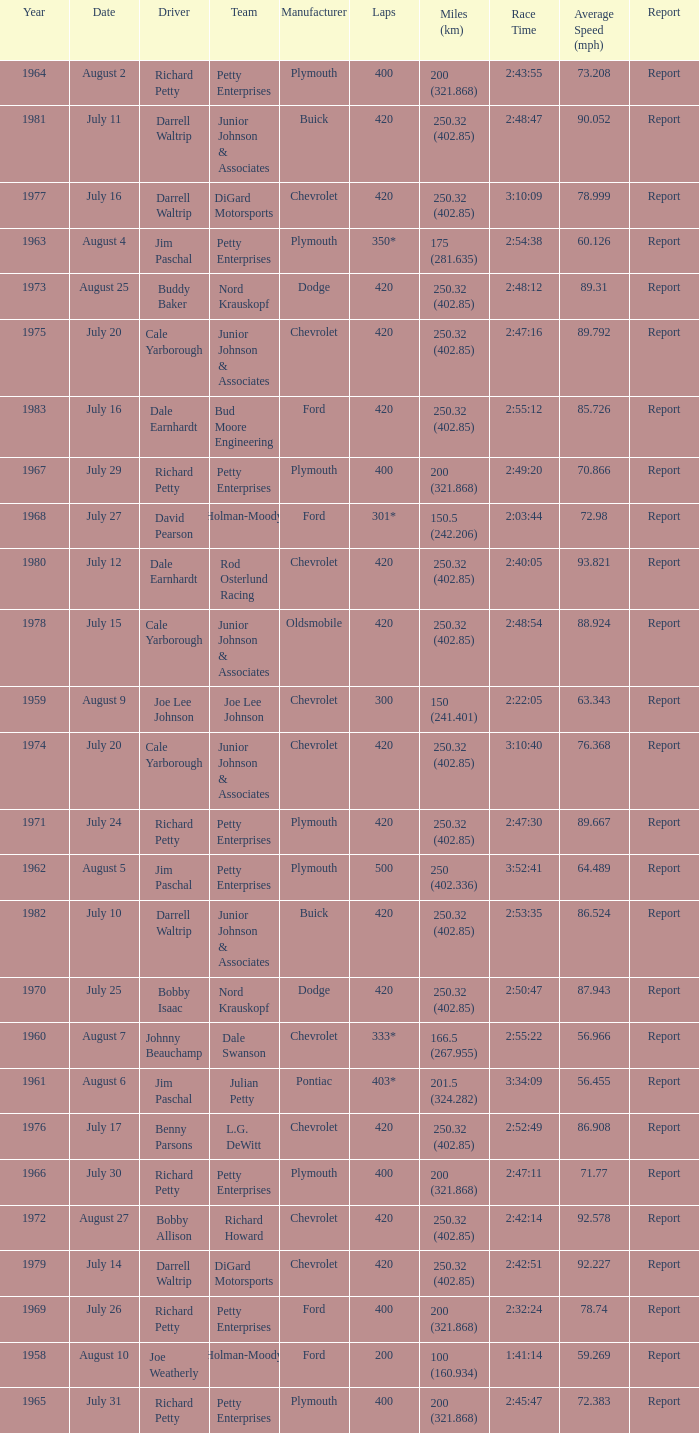Give me the full table as a dictionary. {'header': ['Year', 'Date', 'Driver', 'Team', 'Manufacturer', 'Laps', 'Miles (km)', 'Race Time', 'Average Speed (mph)', 'Report'], 'rows': [['1964', 'August 2', 'Richard Petty', 'Petty Enterprises', 'Plymouth', '400', '200 (321.868)', '2:43:55', '73.208', 'Report'], ['1981', 'July 11', 'Darrell Waltrip', 'Junior Johnson & Associates', 'Buick', '420', '250.32 (402.85)', '2:48:47', '90.052', 'Report'], ['1977', 'July 16', 'Darrell Waltrip', 'DiGard Motorsports', 'Chevrolet', '420', '250.32 (402.85)', '3:10:09', '78.999', 'Report'], ['1963', 'August 4', 'Jim Paschal', 'Petty Enterprises', 'Plymouth', '350*', '175 (281.635)', '2:54:38', '60.126', 'Report'], ['1973', 'August 25', 'Buddy Baker', 'Nord Krauskopf', 'Dodge', '420', '250.32 (402.85)', '2:48:12', '89.31', 'Report'], ['1975', 'July 20', 'Cale Yarborough', 'Junior Johnson & Associates', 'Chevrolet', '420', '250.32 (402.85)', '2:47:16', '89.792', 'Report'], ['1983', 'July 16', 'Dale Earnhardt', 'Bud Moore Engineering', 'Ford', '420', '250.32 (402.85)', '2:55:12', '85.726', 'Report'], ['1967', 'July 29', 'Richard Petty', 'Petty Enterprises', 'Plymouth', '400', '200 (321.868)', '2:49:20', '70.866', 'Report'], ['1968', 'July 27', 'David Pearson', 'Holman-Moody', 'Ford', '301*', '150.5 (242.206)', '2:03:44', '72.98', 'Report'], ['1980', 'July 12', 'Dale Earnhardt', 'Rod Osterlund Racing', 'Chevrolet', '420', '250.32 (402.85)', '2:40:05', '93.821', 'Report'], ['1978', 'July 15', 'Cale Yarborough', 'Junior Johnson & Associates', 'Oldsmobile', '420', '250.32 (402.85)', '2:48:54', '88.924', 'Report'], ['1959', 'August 9', 'Joe Lee Johnson', 'Joe Lee Johnson', 'Chevrolet', '300', '150 (241.401)', '2:22:05', '63.343', 'Report'], ['1974', 'July 20', 'Cale Yarborough', 'Junior Johnson & Associates', 'Chevrolet', '420', '250.32 (402.85)', '3:10:40', '76.368', 'Report'], ['1971', 'July 24', 'Richard Petty', 'Petty Enterprises', 'Plymouth', '420', '250.32 (402.85)', '2:47:30', '89.667', 'Report'], ['1962', 'August 5', 'Jim Paschal', 'Petty Enterprises', 'Plymouth', '500', '250 (402.336)', '3:52:41', '64.489', 'Report'], ['1982', 'July 10', 'Darrell Waltrip', 'Junior Johnson & Associates', 'Buick', '420', '250.32 (402.85)', '2:53:35', '86.524', 'Report'], ['1970', 'July 25', 'Bobby Isaac', 'Nord Krauskopf', 'Dodge', '420', '250.32 (402.85)', '2:50:47', '87.943', 'Report'], ['1960', 'August 7', 'Johnny Beauchamp', 'Dale Swanson', 'Chevrolet', '333*', '166.5 (267.955)', '2:55:22', '56.966', 'Report'], ['1961', 'August 6', 'Jim Paschal', 'Julian Petty', 'Pontiac', '403*', '201.5 (324.282)', '3:34:09', '56.455', 'Report'], ['1976', 'July 17', 'Benny Parsons', 'L.G. DeWitt', 'Chevrolet', '420', '250.32 (402.85)', '2:52:49', '86.908', 'Report'], ['1966', 'July 30', 'Richard Petty', 'Petty Enterprises', 'Plymouth', '400', '200 (321.868)', '2:47:11', '71.77', 'Report'], ['1972', 'August 27', 'Bobby Allison', 'Richard Howard', 'Chevrolet', '420', '250.32 (402.85)', '2:42:14', '92.578', 'Report'], ['1979', 'July 14', 'Darrell Waltrip', 'DiGard Motorsports', 'Chevrolet', '420', '250.32 (402.85)', '2:42:51', '92.227', 'Report'], ['1969', 'July 26', 'Richard Petty', 'Petty Enterprises', 'Ford', '400', '200 (321.868)', '2:32:24', '78.74', 'Report'], ['1958', 'August 10', 'Joe Weatherly', 'Holman-Moody', 'Ford', '200', '100 (160.934)', '1:41:14', '59.269', 'Report'], ['1965', 'July 31', 'Richard Petty', 'Petty Enterprises', 'Plymouth', '400', '200 (321.868)', '2:45:47', '72.383', 'Report']]} What year had a race with 301* laps? 1968.0. 